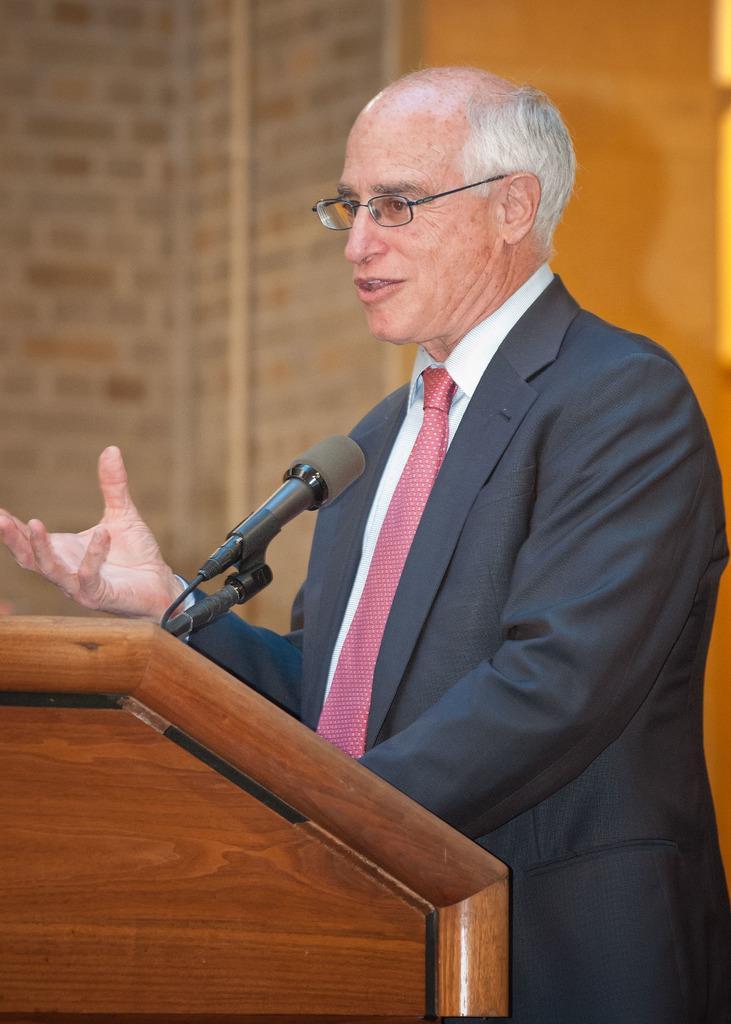Describe this image in one or two sentences. In this picture we can see a man who is talking on the mike. He is in black color suit. He has spectacles. And this is the podium. On the background there is a wall. 